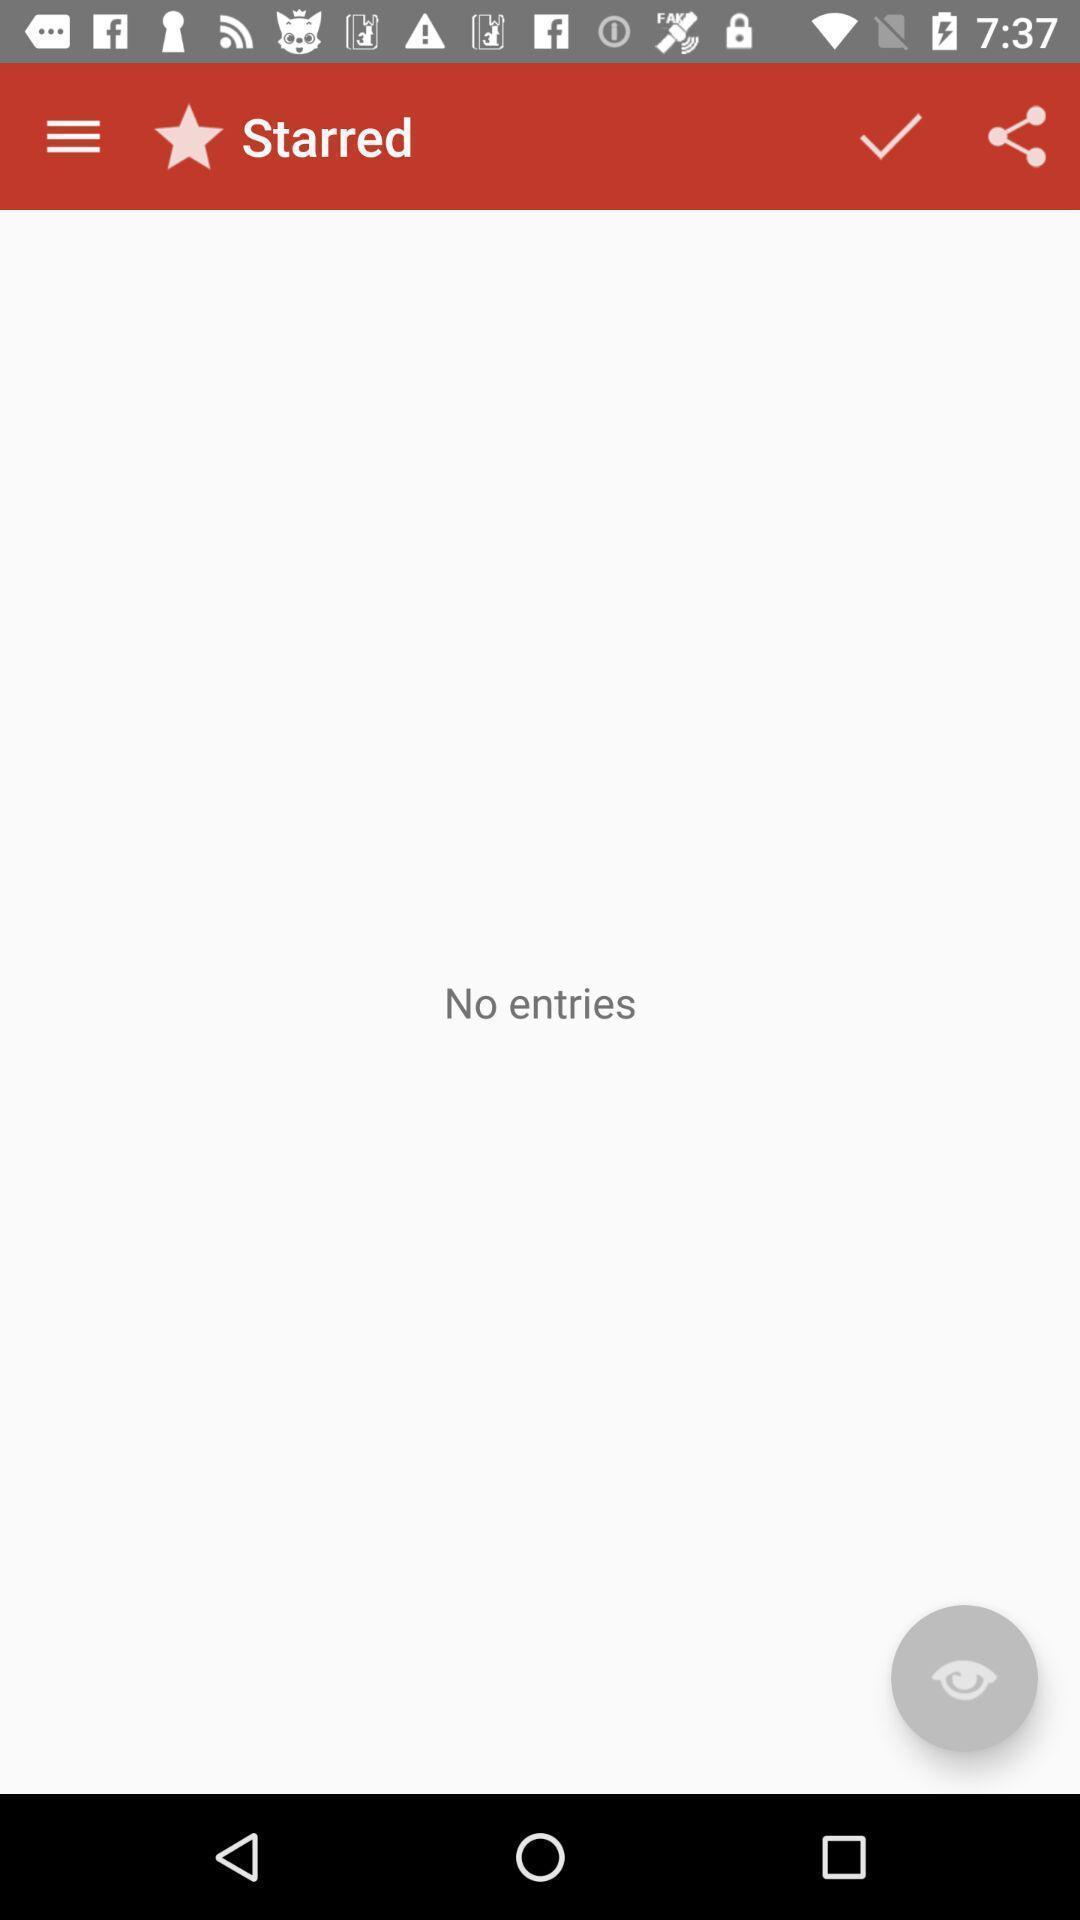What details can you identify in this image? Page shows starred with no entries. 